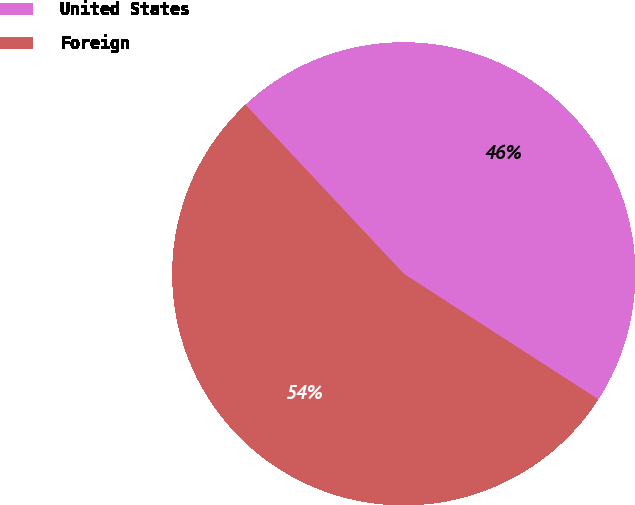Convert chart. <chart><loc_0><loc_0><loc_500><loc_500><pie_chart><fcel>United States<fcel>Foreign<nl><fcel>46.1%<fcel>53.9%<nl></chart> 